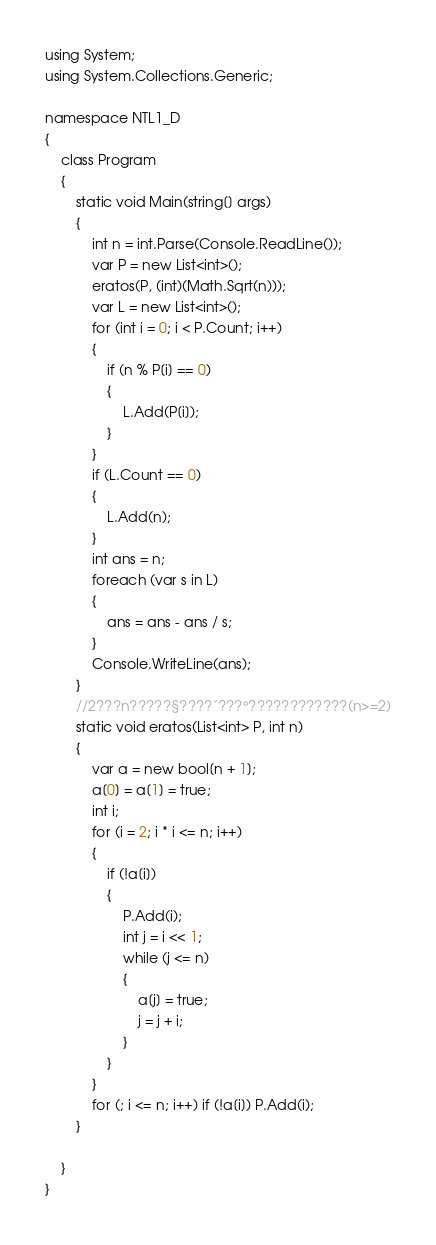Convert code to text. <code><loc_0><loc_0><loc_500><loc_500><_C#_>using System;
using System.Collections.Generic;

namespace NTL1_D
{
    class Program
    {
        static void Main(string[] args)
        {
            int n = int.Parse(Console.ReadLine());
            var P = new List<int>();
            eratos(P, (int)(Math.Sqrt(n)));
            var L = new List<int>();
            for (int i = 0; i < P.Count; i++)
            {
                if (n % P[i] == 0)
                {
                    L.Add(P[i]);
                }
            }
            if (L.Count == 0)
            {
                L.Add(n);
            }
            int ans = n;
            foreach (var s in L)
            {
                ans = ans - ans / s;
            }
            Console.WriteLine(ans);
        }
        //2???n?????§????´???°????????????(n>=2)
        static void eratos(List<int> P, int n)
        {
            var a = new bool[n + 1];
            a[0] = a[1] = true;
            int i;
            for (i = 2; i * i <= n; i++)
            {
                if (!a[i])
                {
                    P.Add(i);
                    int j = i << 1;
                    while (j <= n)
                    {
                        a[j] = true;
                        j = j + i;
                    }
                }
            }
            for (; i <= n; i++) if (!a[i]) P.Add(i);
        }

    }
}</code> 